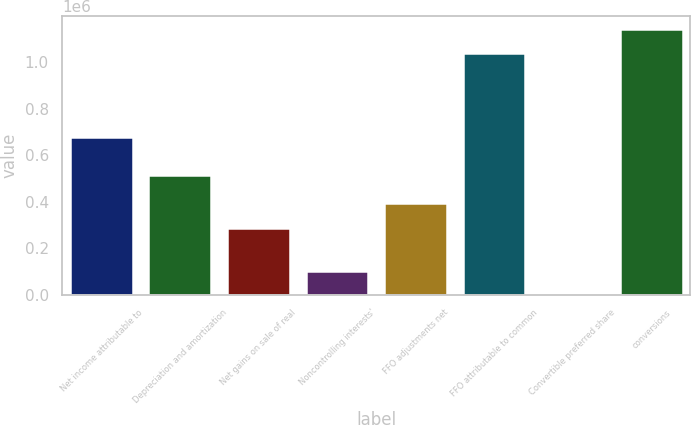Convert chart to OTSL. <chart><loc_0><loc_0><loc_500><loc_500><bar_chart><fcel>Net income attributable to<fcel>Depreciation and amortization<fcel>Net gains on sale of real<fcel>Noncontrolling interests'<fcel>FFO adjustments net<fcel>FFO attributable to common<fcel>Convertible preferred share<fcel>conversions<nl><fcel>679856<fcel>514085<fcel>289117<fcel>103986<fcel>393011<fcel>1.03894e+06<fcel>92<fcel>1.14284e+06<nl></chart> 